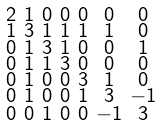<formula> <loc_0><loc_0><loc_500><loc_500>\begin{smallmatrix} 2 & 1 & 0 & 0 & 0 & 0 & 0 \\ 1 & 3 & 1 & 1 & 1 & 1 & 0 \\ 0 & 1 & 3 & 1 & 0 & 0 & 1 \\ 0 & 1 & 1 & 3 & 0 & 0 & 0 \\ 0 & 1 & 0 & 0 & 3 & 1 & 0 \\ 0 & 1 & 0 & 0 & 1 & 3 & - 1 \\ 0 & 0 & 1 & 0 & 0 & - 1 & 3 \end{smallmatrix}</formula> 